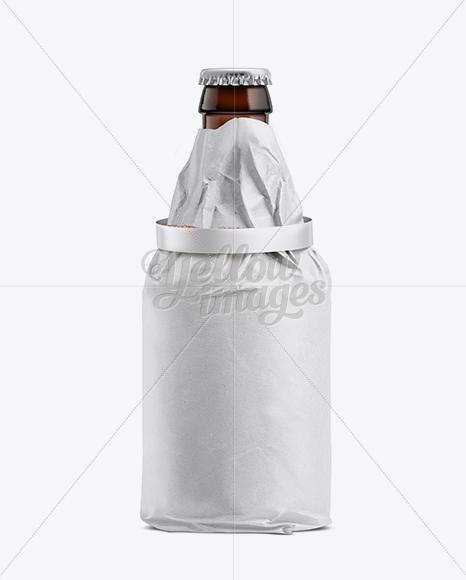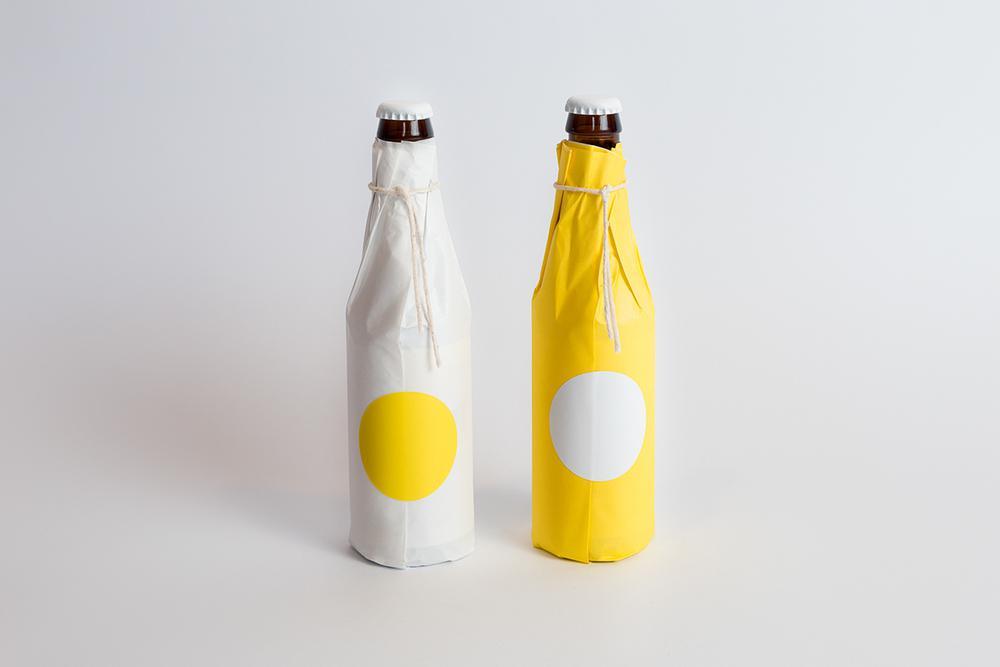The first image is the image on the left, the second image is the image on the right. Evaluate the accuracy of this statement regarding the images: "Each image contains only paper-wrapped bottles, and the left image features one wide-bottomed bottled with a ring shape around the neck and its cap exposed.". Is it true? Answer yes or no. Yes. The first image is the image on the left, the second image is the image on the right. Evaluate the accuracy of this statement regarding the images: "There are exactly two bottles wrapped in paper.". Is it true? Answer yes or no. No. 